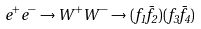<formula> <loc_0><loc_0><loc_500><loc_500>e ^ { + } e ^ { - } \rightarrow W ^ { + } W ^ { - } \rightarrow ( f _ { 1 } \bar { f } _ { 2 } ) ( f _ { 3 } \bar { f } _ { 4 } )</formula> 